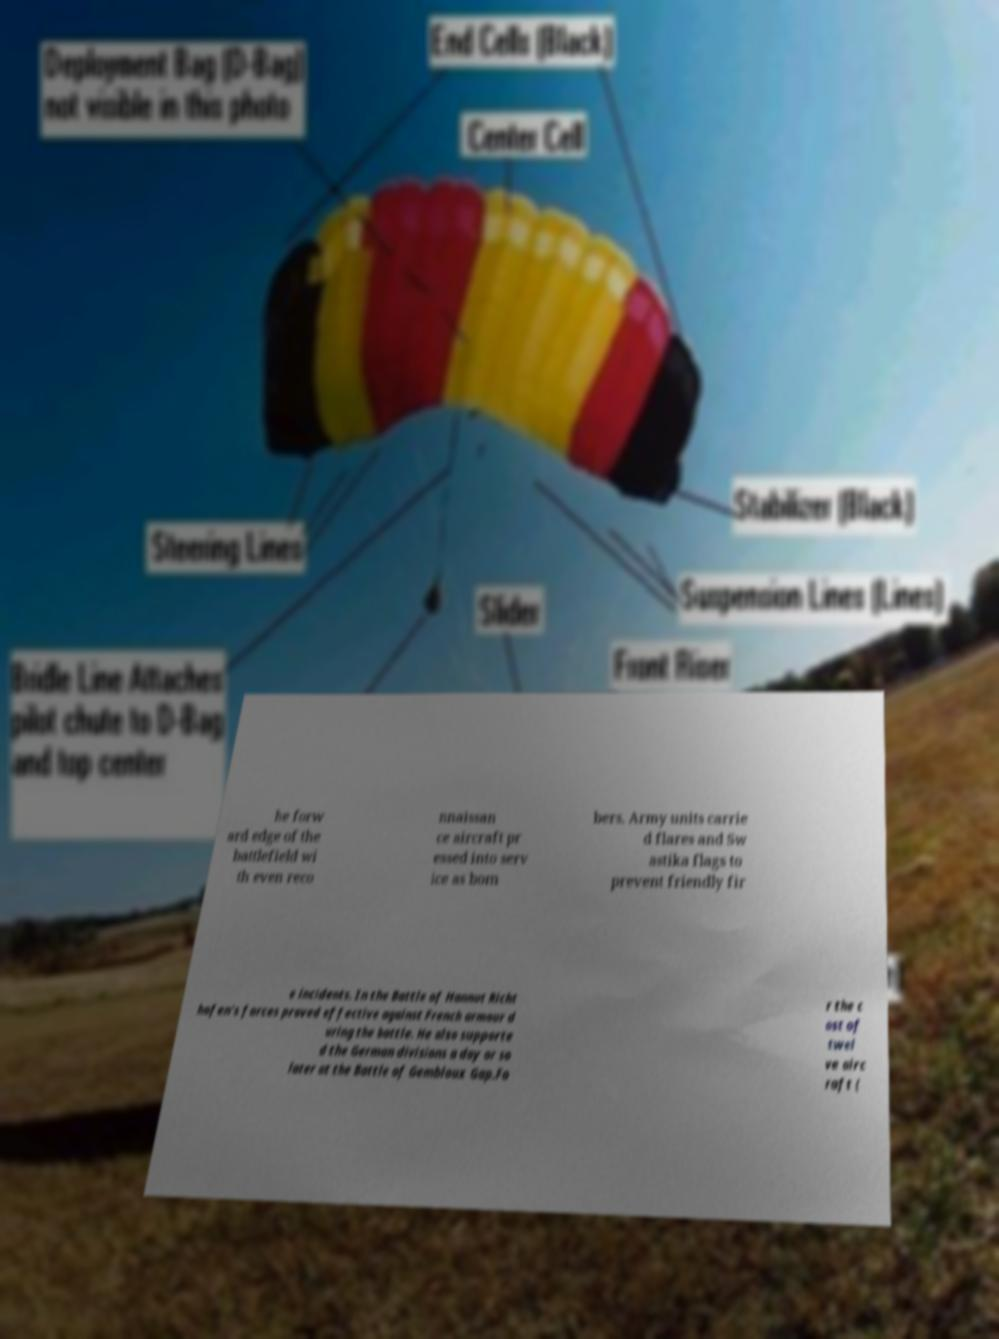I need the written content from this picture converted into text. Can you do that? he forw ard edge of the battlefield wi th even reco nnaissan ce aircraft pr essed into serv ice as bom bers. Army units carrie d flares and Sw astika flags to prevent friendly fir e incidents. In the Battle of Hannut Richt hofen's forces proved effective against French armour d uring the battle. He also supporte d the German divisions a day or so later at the Battle of Gembloux Gap.Fo r the c ost of twel ve airc raft ( 